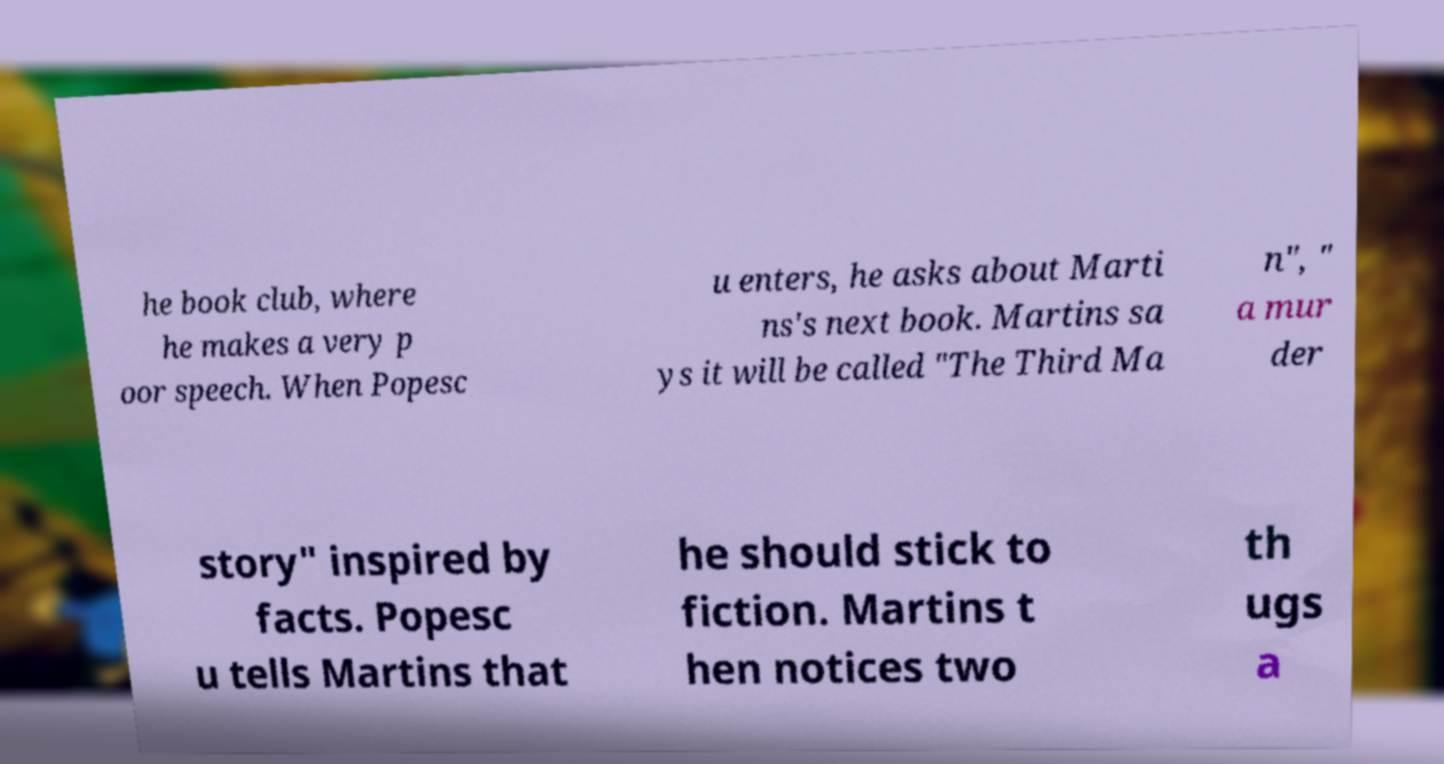There's text embedded in this image that I need extracted. Can you transcribe it verbatim? he book club, where he makes a very p oor speech. When Popesc u enters, he asks about Marti ns's next book. Martins sa ys it will be called "The Third Ma n", " a mur der story" inspired by facts. Popesc u tells Martins that he should stick to fiction. Martins t hen notices two th ugs a 